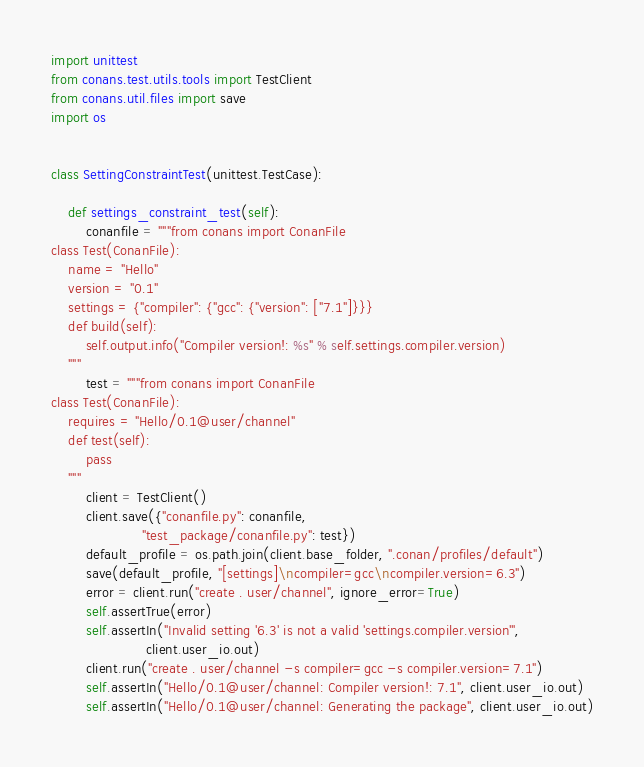<code> <loc_0><loc_0><loc_500><loc_500><_Python_>import unittest
from conans.test.utils.tools import TestClient
from conans.util.files import save
import os


class SettingConstraintTest(unittest.TestCase):

    def settings_constraint_test(self):
        conanfile = """from conans import ConanFile
class Test(ConanFile):
    name = "Hello"
    version = "0.1"
    settings = {"compiler": {"gcc": {"version": ["7.1"]}}}
    def build(self):
        self.output.info("Compiler version!: %s" % self.settings.compiler.version)
    """
        test = """from conans import ConanFile
class Test(ConanFile):
    requires = "Hello/0.1@user/channel"
    def test(self):
        pass
    """
        client = TestClient()
        client.save({"conanfile.py": conanfile,
                     "test_package/conanfile.py": test})
        default_profile = os.path.join(client.base_folder, ".conan/profiles/default")
        save(default_profile, "[settings]\ncompiler=gcc\ncompiler.version=6.3")
        error = client.run("create . user/channel", ignore_error=True)
        self.assertTrue(error)
        self.assertIn("Invalid setting '6.3' is not a valid 'settings.compiler.version'",
                      client.user_io.out)
        client.run("create . user/channel -s compiler=gcc -s compiler.version=7.1")
        self.assertIn("Hello/0.1@user/channel: Compiler version!: 7.1", client.user_io.out)
        self.assertIn("Hello/0.1@user/channel: Generating the package", client.user_io.out)
</code> 